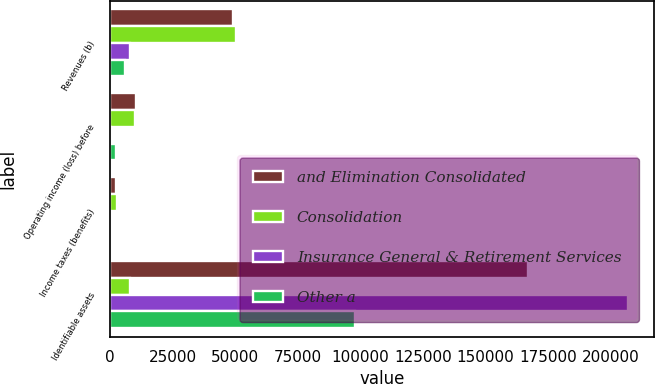Convert chart to OTSL. <chart><loc_0><loc_0><loc_500><loc_500><stacked_bar_chart><ecel><fcel>Revenues (b)<fcel>Operating income (loss) before<fcel>Income taxes (benefits)<fcel>Identifiable assets<nl><fcel>and Elimination Consolidated<fcel>49206<fcel>10412<fcel>2351<fcel>167004<nl><fcel>Consolidation<fcel>50163<fcel>10032<fcel>2861<fcel>8010<nl><fcel>Insurance General & Retirement Services<fcel>8010<fcel>524<fcel>23<fcel>206845<nl><fcel>Other a<fcel>5814<fcel>2346<fcel>606<fcel>97913<nl></chart> 